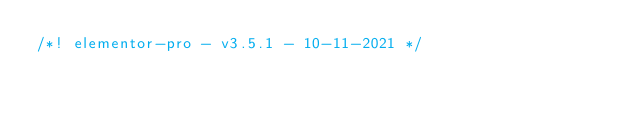<code> <loc_0><loc_0><loc_500><loc_500><_CSS_>/*! elementor-pro - v3.5.1 - 10-11-2021 */</code> 